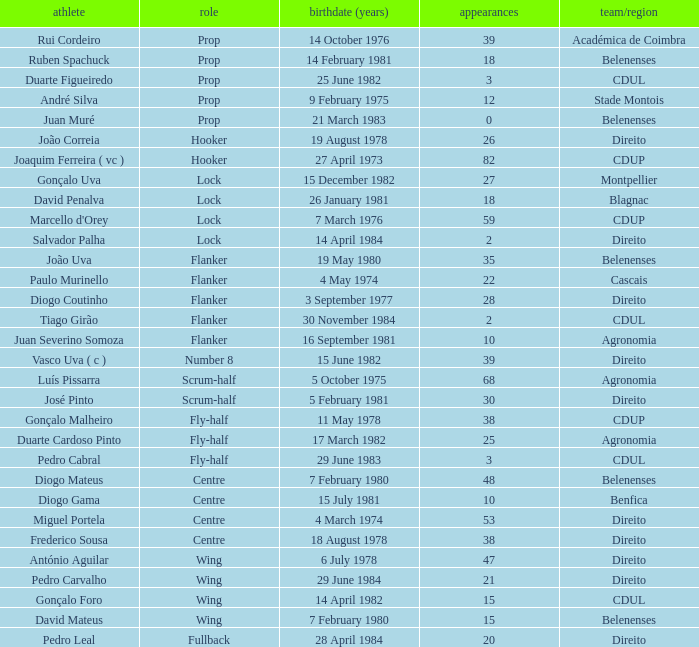Which player has a Club/province of direito, less than 21 caps, and a Position of lock? Salvador Palha. 